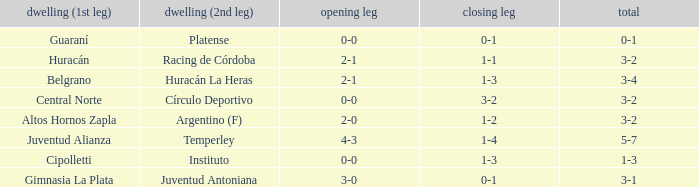Which team played their first leg at home with an aggregate score of 3-4? Belgrano. 